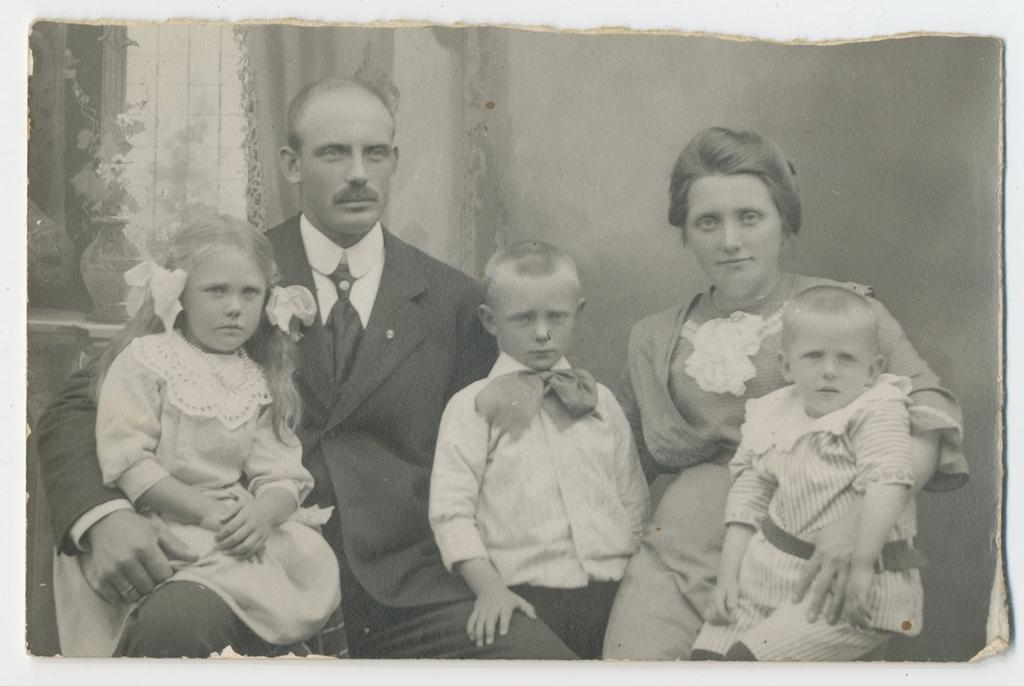What is the main subject of the image? The main subject of the image is a photo. Where is the photo located in the image? The photo is on an object. How many people are in the photo? There are five persons in the photo. What type of lizards can be seen in the photo? There are no lizards present in the photo; it features five persons. What is the name of the daughter in the photo? There is no mention of a daughter in the image or the photo, as it only states that there are five persons. 